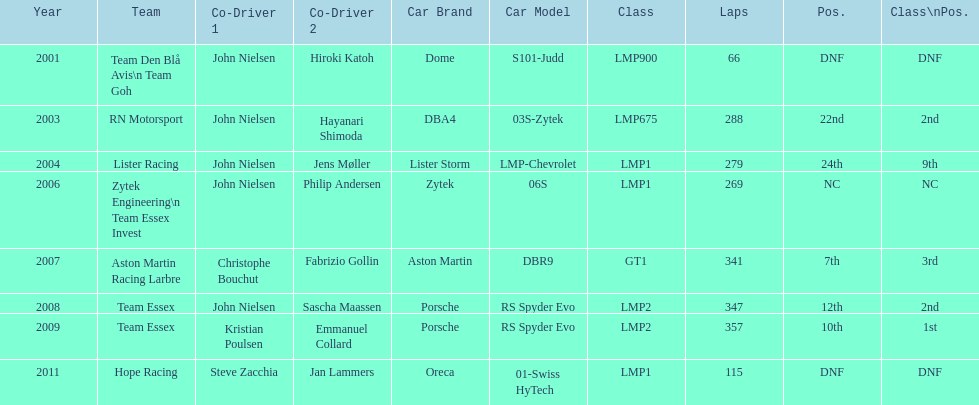What model car was the most used? Porsche RS Spyder. 